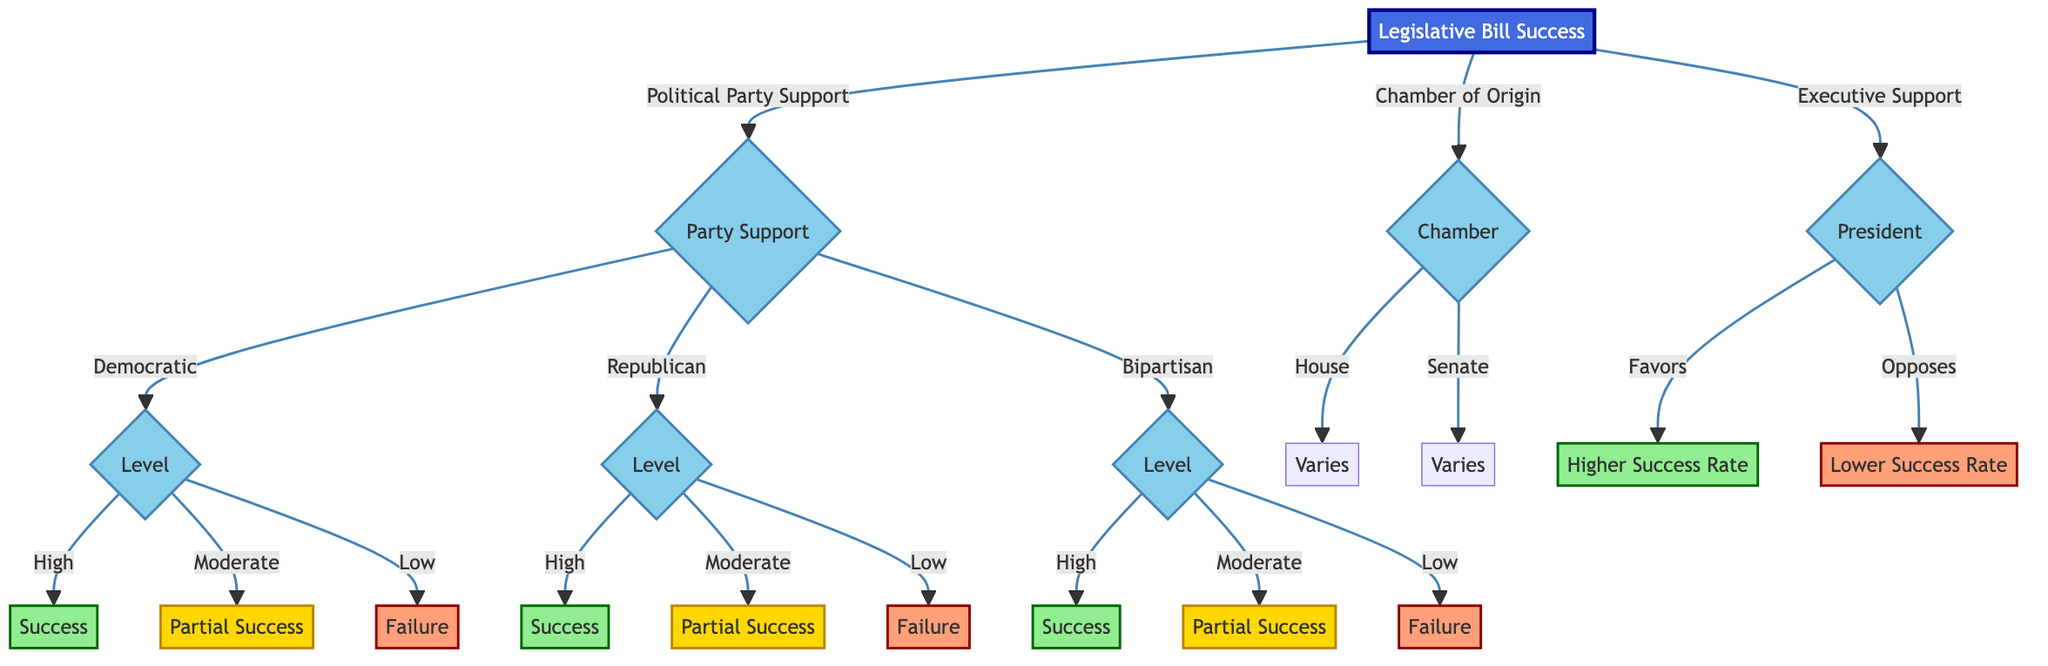What is the outcome if there is high bipartisan support? From the diagram, if there is high bipartisan support, it leads to the outcome labeled as "Success." This is directly shown in the "Bipartisan Support" branch under "Level."
Answer: Success Which chamber has a variable outcome based on committee support and majority party control? The diagram indicates that the "House of Representatives" has an outcome that "Varies," influenced by factors like committee support and majority party control. This is found in the "Chamber of Origin" section.
Answer: House of Representatives What are examples of bills that faced low Democratic support? Looking at the "Democratic Support" section under "Low," two examples listed are "Public Option for Healthcare" and "Green New Deal." These examples represent legislative initiatives that did not gain sufficient support.
Answer: Public Option for Healthcare, Green New Deal What is the outcome of a bill supported moderately by Republicans? The diagram shows that if a bill has moderate Republican support, the outcome is categorized as "Partial Success." This is depicted within the Republican branch of the decision tree.
Answer: Partial Success What effects does presidential support have on legislative bill success? According to the diagram, when the president favors a bill, it results in a "Higher Success Rate." In contrast, if the president opposes it, the outcome is a "Lower Success Rate." This is specifically located under the "Executive Support" section.
Answer: Higher Success Rate What happens to a bill with high Democratic support? Based on the decision tree, a bill with high Democratic support leads directly to the outcome of "Success." This outcome is indicated in the corresponding section for Democratic support.
Answer: Success Which outcome results from low bipartisan support? The diagram states that low bipartisan support results in an outcome of "Failure." This conclusion is found in the "Bipartisan Support" branch, specifically under the "Low" level category.
Answer: Failure How many outcomes are directly associated with high Republican support? There are three potential outcomes directly associated with high Republican support: "Success," "Partial Success," and "Failure." The decision tree has clear branching for each support level within the Republican category.
Answer: Three outcomes 